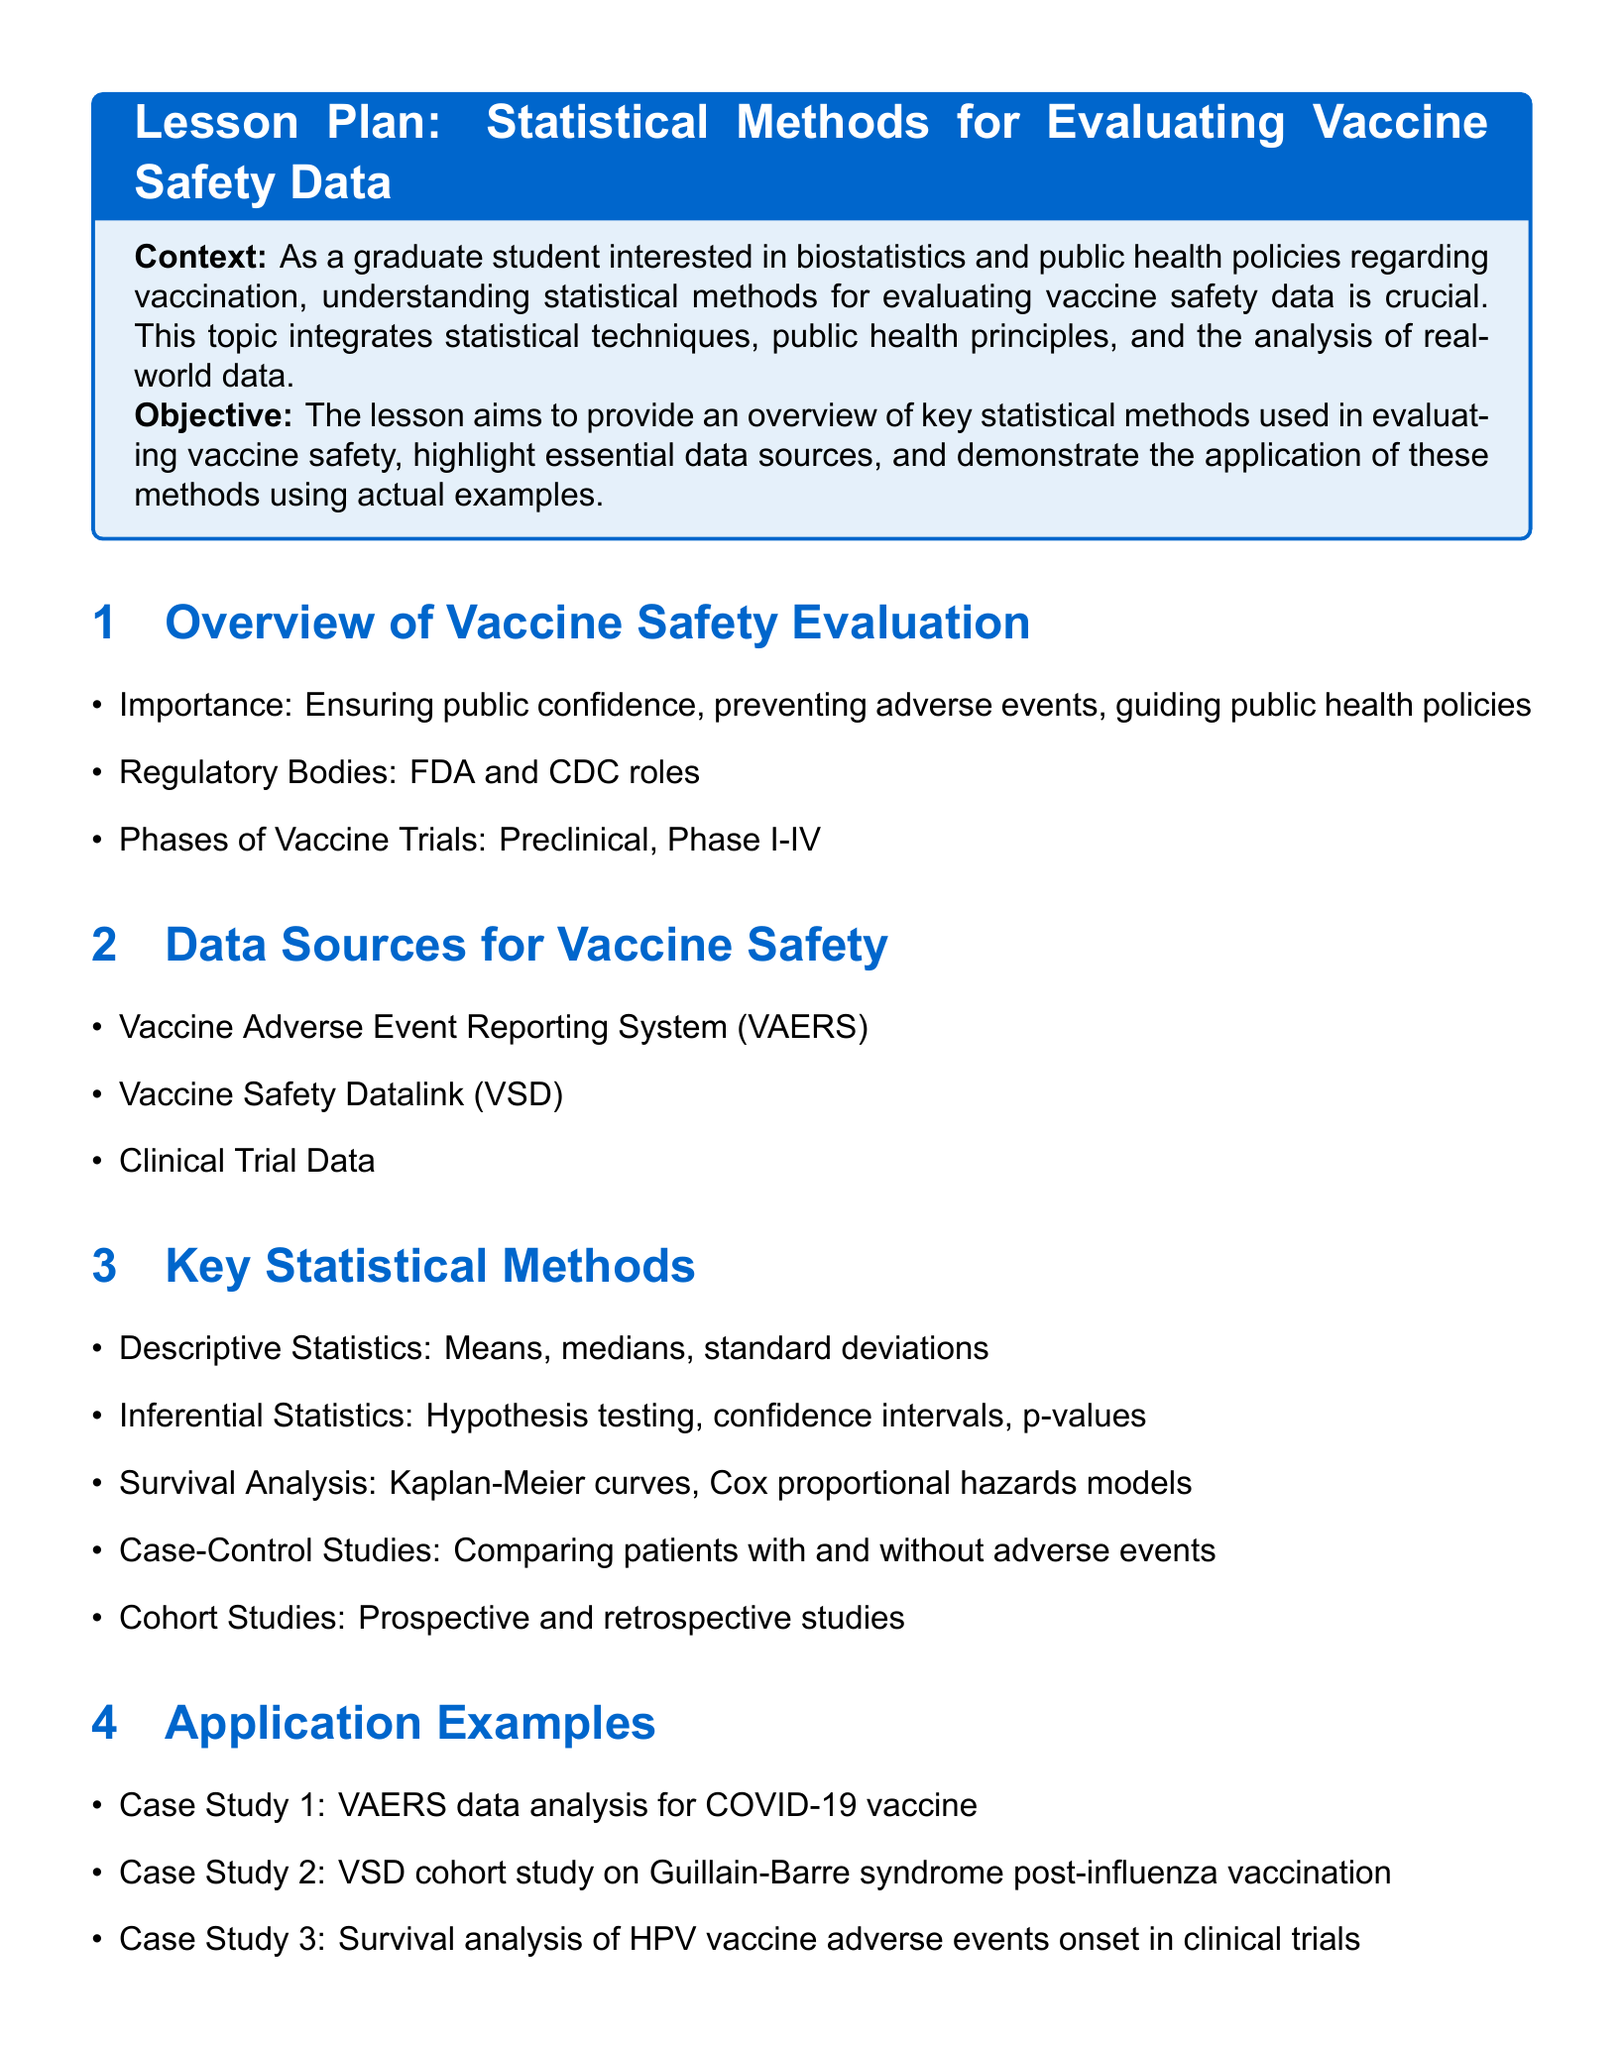What is the title of the lesson plan? The title is the primary heading of the lesson plan, which is "Lesson Plan: Statistical Methods for Evaluating Vaccine Safety Data."
Answer: Lesson Plan: Statistical Methods for Evaluating Vaccine Safety Data What is the first key statistical method mentioned? The first key statistical method is listed under the "Key Statistical Methods" section of the document.
Answer: Descriptive Statistics Which regulatory bodies are mentioned in the document? The regulatory bodies are listed in the "Overview of Vaccine Safety Evaluation" section, specifically referring to their roles.
Answer: FDA and CDC What type of analysis is used in Case Study 3? This information is specified under the "Application Examples" section of the document for Case Study 3.
Answer: Survival analysis What is one challenge mentioned regarding vaccine safety evaluation? The challenges are outlined in the "Conclusion and Future Directions" section, providing insight into issues faced in the evaluation process.
Answer: VAERS underreporting Which data source is listed first for vaccine safety? The data sources are listed in the "Data Sources for Vaccine Safety" section, indicating their importance for evaluation.
Answer: Vaccine Adverse Event Reporting System (VAERS) What is the main objective of the lesson? The objective summarizes the aims of the lesson plan and is stated clearly in the document.
Answer: Provide an overview of key statistical methods used in evaluating vaccine safety What future direction is suggested in the conclusion? This information is noted in the "Conclusion and Future Directions" section, addressing forward-looking strategies.
Answer: Improving post-marketing surveillance 